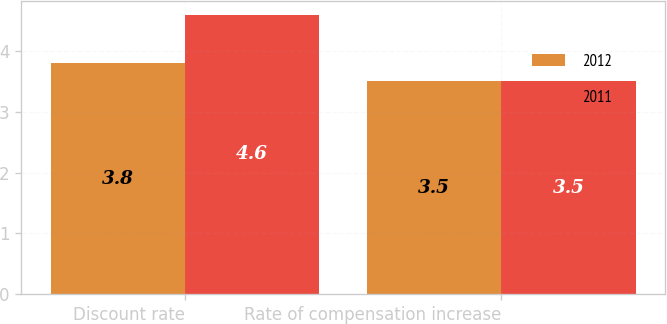Convert chart. <chart><loc_0><loc_0><loc_500><loc_500><stacked_bar_chart><ecel><fcel>Discount rate<fcel>Rate of compensation increase<nl><fcel>2012<fcel>3.8<fcel>3.5<nl><fcel>2011<fcel>4.6<fcel>3.5<nl></chart> 